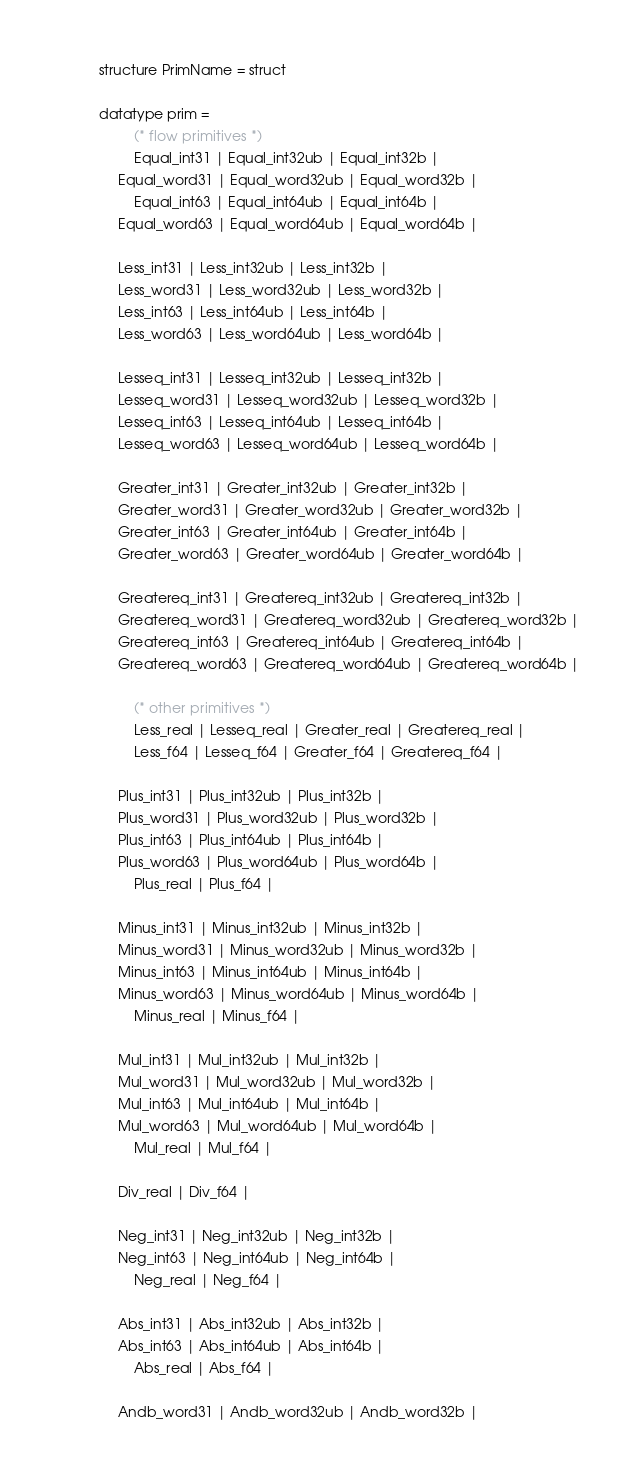Convert code to text. <code><loc_0><loc_0><loc_500><loc_500><_SML_>structure PrimName = struct

datatype prim =
         (* flow primitives *)
         Equal_int31 | Equal_int32ub | Equal_int32b |
	 Equal_word31 | Equal_word32ub | Equal_word32b |
         Equal_int63 | Equal_int64ub | Equal_int64b |
	 Equal_word63 | Equal_word64ub | Equal_word64b |

	 Less_int31 | Less_int32ub | Less_int32b |
	 Less_word31 | Less_word32ub | Less_word32b |
	 Less_int63 | Less_int64ub | Less_int64b |
	 Less_word63 | Less_word64ub | Less_word64b |

	 Lesseq_int31 | Lesseq_int32ub | Lesseq_int32b |
	 Lesseq_word31 | Lesseq_word32ub | Lesseq_word32b |
	 Lesseq_int63 | Lesseq_int64ub | Lesseq_int64b |
	 Lesseq_word63 | Lesseq_word64ub | Lesseq_word64b |

	 Greater_int31 | Greater_int32ub | Greater_int32b |
	 Greater_word31 | Greater_word32ub | Greater_word32b |
	 Greater_int63 | Greater_int64ub | Greater_int64b |
	 Greater_word63 | Greater_word64ub | Greater_word64b |

	 Greatereq_int31 | Greatereq_int32ub | Greatereq_int32b |
	 Greatereq_word31 | Greatereq_word32ub | Greatereq_word32b |
	 Greatereq_int63 | Greatereq_int64ub | Greatereq_int64b |
	 Greatereq_word63 | Greatereq_word64ub | Greatereq_word64b |

         (* other primitives *)
         Less_real | Lesseq_real | Greater_real | Greatereq_real |
         Less_f64 | Lesseq_f64 | Greater_f64 | Greatereq_f64 |

	 Plus_int31 | Plus_int32ub | Plus_int32b |
	 Plus_word31 | Plus_word32ub | Plus_word32b |
	 Plus_int63 | Plus_int64ub | Plus_int64b |
	 Plus_word63 | Plus_word64ub | Plus_word64b |
         Plus_real | Plus_f64 |

	 Minus_int31 | Minus_int32ub | Minus_int32b |
	 Minus_word31 | Minus_word32ub | Minus_word32b |
	 Minus_int63 | Minus_int64ub | Minus_int64b |
	 Minus_word63 | Minus_word64ub | Minus_word64b |
         Minus_real | Minus_f64 |

	 Mul_int31 | Mul_int32ub | Mul_int32b |
	 Mul_word31 | Mul_word32ub | Mul_word32b |
	 Mul_int63 | Mul_int64ub | Mul_int64b |
	 Mul_word63 | Mul_word64ub | Mul_word64b |
         Mul_real | Mul_f64 |

	 Div_real | Div_f64 |

	 Neg_int31 | Neg_int32ub | Neg_int32b |
	 Neg_int63 | Neg_int64ub | Neg_int64b |
         Neg_real | Neg_f64 |

	 Abs_int31 | Abs_int32ub | Abs_int32b |
	 Abs_int63 | Abs_int64ub | Abs_int64b |
         Abs_real | Abs_f64 |

	 Andb_word31 | Andb_word32ub | Andb_word32b |</code> 